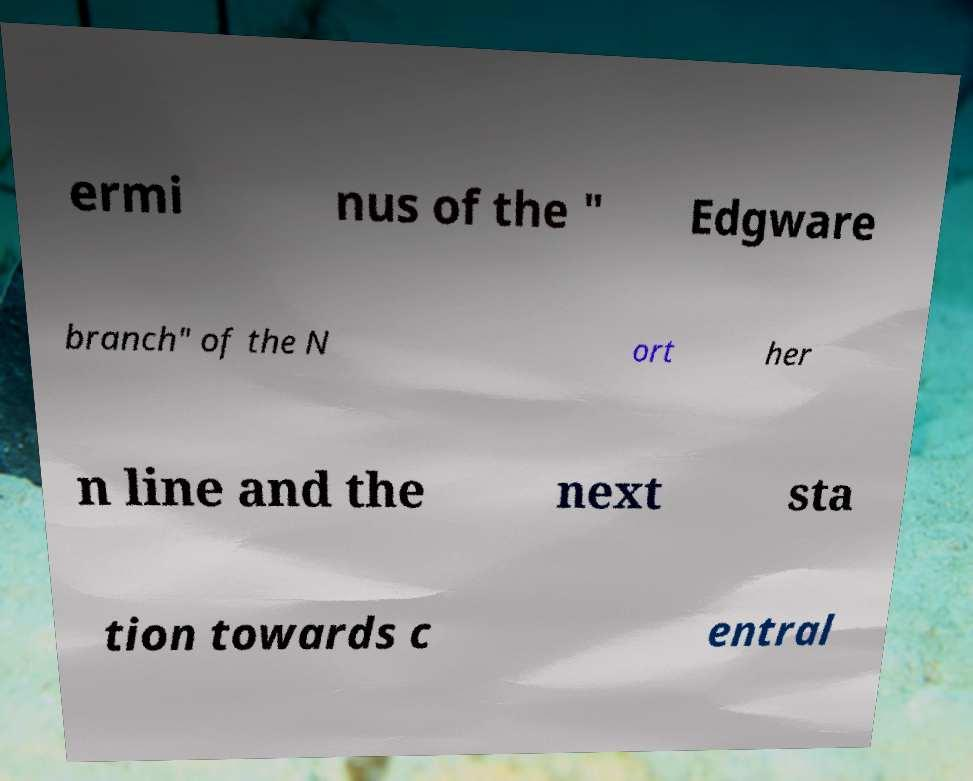Please read and relay the text visible in this image. What does it say? ermi nus of the " Edgware branch" of the N ort her n line and the next sta tion towards c entral 